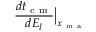Convert formula to latex. <formula><loc_0><loc_0><loc_500><loc_500>\frac { d t _ { c m } } { d E _ { l } } \Big | _ { x _ { m a } }</formula> 